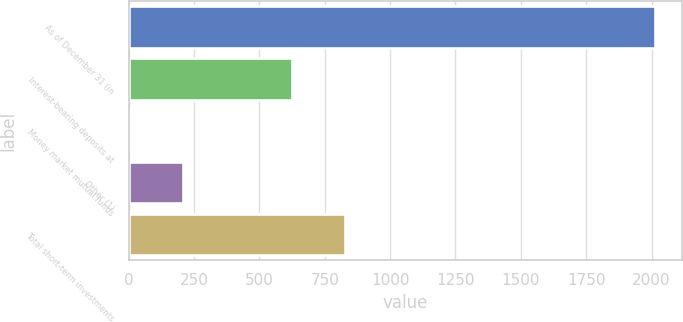Convert chart. <chart><loc_0><loc_0><loc_500><loc_500><bar_chart><fcel>As of December 31 (in<fcel>Interest-bearing deposits at<fcel>Money market mutual funds<fcel>Other (1)<fcel>Total short-term investments<nl><fcel>2014<fcel>626.5<fcel>7.3<fcel>207.97<fcel>827.17<nl></chart> 